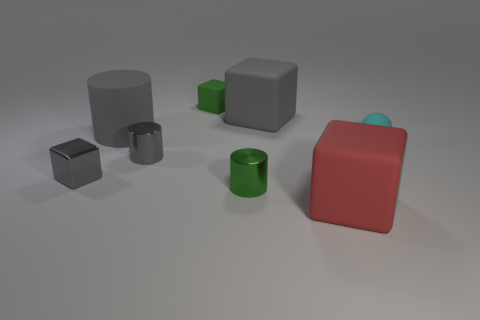Do the big red block and the tiny cube behind the small rubber sphere have the same material?
Ensure brevity in your answer.  Yes. What number of objects are either big objects right of the small gray shiny cylinder or blocks?
Provide a short and direct response. 4. There is a green thing that is behind the large gray matte object that is on the right side of the gray matte object that is to the left of the green cylinder; how big is it?
Offer a terse response. Small. There is a tiny cylinder that is the same color as the large cylinder; what is it made of?
Your response must be concise. Metal. Are there any other things that have the same shape as the tiny cyan matte thing?
Provide a succinct answer. No. How big is the gray object right of the gray shiny object that is right of the big gray matte cylinder?
Your response must be concise. Large. How many small things are green shiny objects or shiny cubes?
Offer a very short reply. 2. Is the number of big matte cubes less than the number of green balls?
Offer a terse response. No. Are there any other things that have the same size as the rubber ball?
Ensure brevity in your answer.  Yes. Is the sphere the same color as the shiny cube?
Make the answer very short. No. 